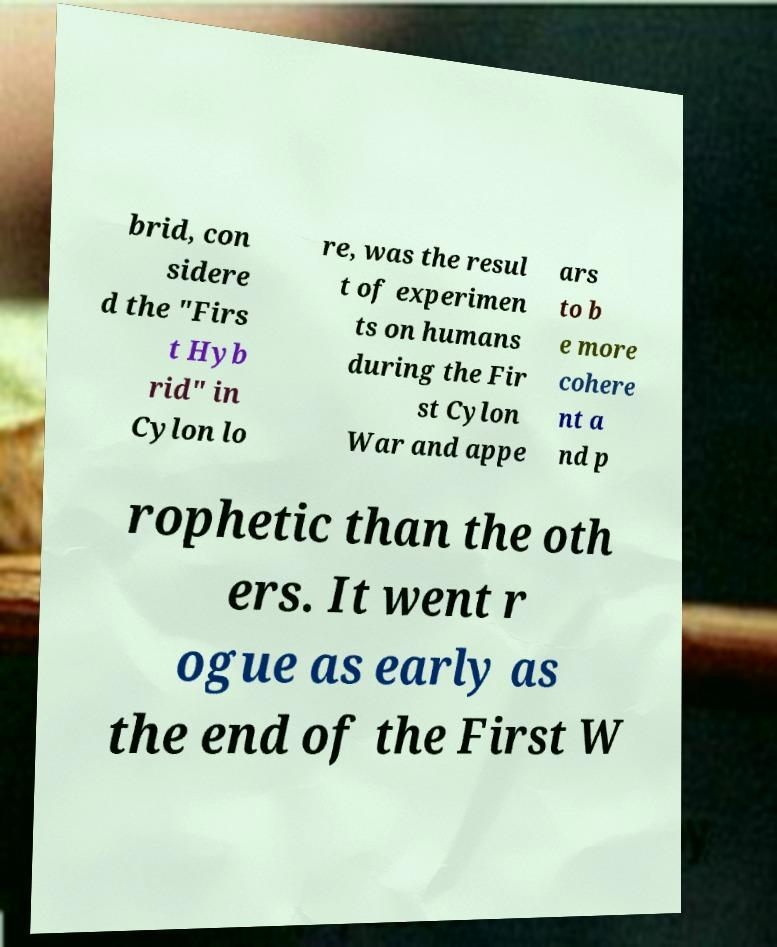Could you extract and type out the text from this image? brid, con sidere d the "Firs t Hyb rid" in Cylon lo re, was the resul t of experimen ts on humans during the Fir st Cylon War and appe ars to b e more cohere nt a nd p rophetic than the oth ers. It went r ogue as early as the end of the First W 